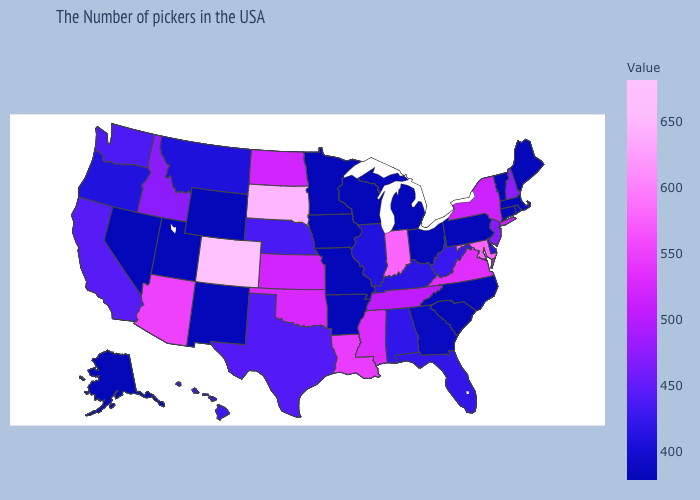Among the states that border New Hampshire , which have the highest value?
Keep it brief. Maine, Massachusetts, Vermont. Among the states that border Mississippi , which have the lowest value?
Write a very short answer. Arkansas. Which states have the lowest value in the USA?
Be succinct. Maine, Massachusetts, Vermont, Connecticut, Pennsylvania, North Carolina, South Carolina, Ohio, Michigan, Wisconsin, Missouri, Arkansas, Minnesota, Iowa, Wyoming, New Mexico, Utah, Nevada, Alaska. 